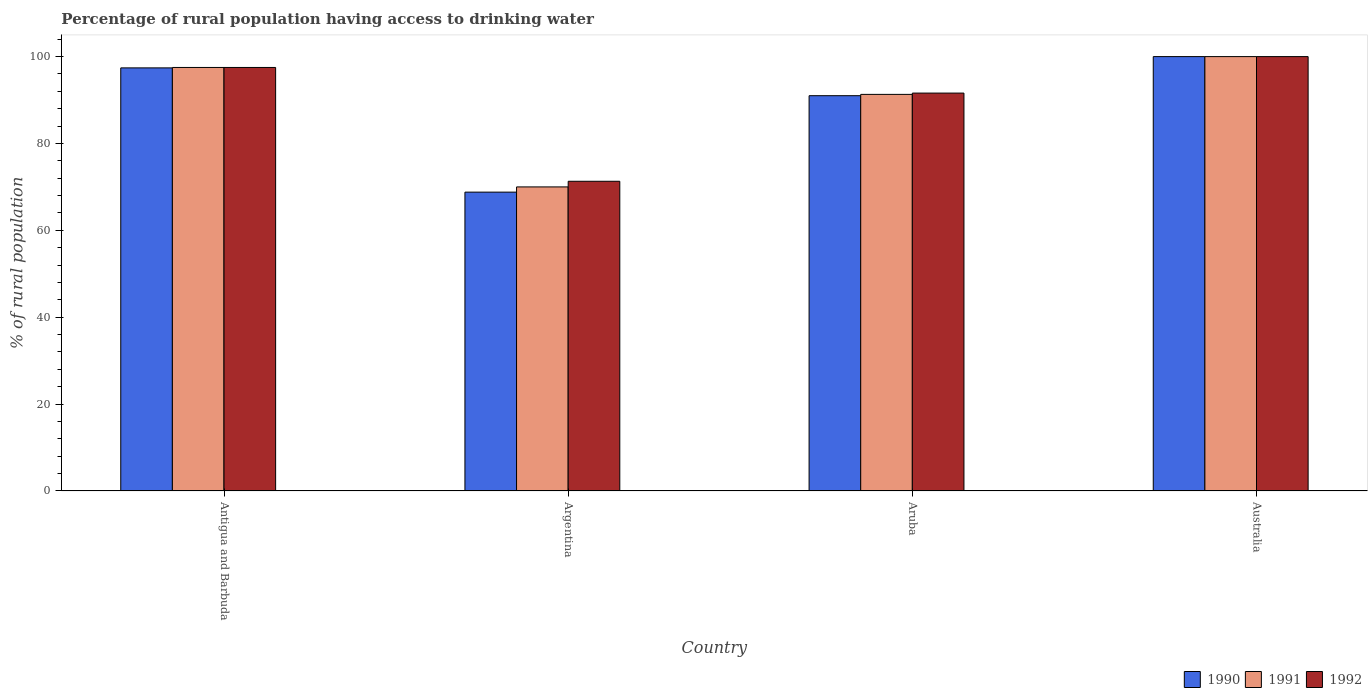How many different coloured bars are there?
Keep it short and to the point. 3. How many groups of bars are there?
Offer a terse response. 4. Are the number of bars per tick equal to the number of legend labels?
Provide a short and direct response. Yes. Are the number of bars on each tick of the X-axis equal?
Your answer should be compact. Yes. How many bars are there on the 2nd tick from the left?
Provide a short and direct response. 3. How many bars are there on the 2nd tick from the right?
Make the answer very short. 3. What is the label of the 1st group of bars from the left?
Ensure brevity in your answer.  Antigua and Barbuda. In how many cases, is the number of bars for a given country not equal to the number of legend labels?
Provide a succinct answer. 0. What is the percentage of rural population having access to drinking water in 1990 in Argentina?
Your answer should be very brief. 68.8. Across all countries, what is the minimum percentage of rural population having access to drinking water in 1992?
Provide a short and direct response. 71.3. In which country was the percentage of rural population having access to drinking water in 1992 minimum?
Give a very brief answer. Argentina. What is the total percentage of rural population having access to drinking water in 1990 in the graph?
Your answer should be very brief. 357.2. What is the difference between the percentage of rural population having access to drinking water in 1992 in Antigua and Barbuda and that in Argentina?
Offer a very short reply. 26.2. What is the difference between the percentage of rural population having access to drinking water in 1991 in Aruba and the percentage of rural population having access to drinking water in 1992 in Argentina?
Ensure brevity in your answer.  20. What is the average percentage of rural population having access to drinking water in 1991 per country?
Make the answer very short. 89.7. What is the difference between the percentage of rural population having access to drinking water of/in 1991 and percentage of rural population having access to drinking water of/in 1990 in Argentina?
Provide a short and direct response. 1.2. What is the ratio of the percentage of rural population having access to drinking water in 1991 in Aruba to that in Australia?
Your answer should be compact. 0.91. What is the difference between the highest and the second highest percentage of rural population having access to drinking water in 1990?
Keep it short and to the point. 6.4. What is the difference between the highest and the lowest percentage of rural population having access to drinking water in 1992?
Provide a short and direct response. 28.7. In how many countries, is the percentage of rural population having access to drinking water in 1991 greater than the average percentage of rural population having access to drinking water in 1991 taken over all countries?
Your response must be concise. 3. Is the sum of the percentage of rural population having access to drinking water in 1990 in Antigua and Barbuda and Aruba greater than the maximum percentage of rural population having access to drinking water in 1992 across all countries?
Your response must be concise. Yes. What does the 1st bar from the left in Antigua and Barbuda represents?
Make the answer very short. 1990. What does the 1st bar from the right in Australia represents?
Ensure brevity in your answer.  1992. What is the difference between two consecutive major ticks on the Y-axis?
Give a very brief answer. 20. Are the values on the major ticks of Y-axis written in scientific E-notation?
Your answer should be very brief. No. Does the graph contain any zero values?
Offer a terse response. No. What is the title of the graph?
Your answer should be compact. Percentage of rural population having access to drinking water. What is the label or title of the X-axis?
Your answer should be very brief. Country. What is the label or title of the Y-axis?
Provide a short and direct response. % of rural population. What is the % of rural population of 1990 in Antigua and Barbuda?
Your answer should be compact. 97.4. What is the % of rural population in 1991 in Antigua and Barbuda?
Make the answer very short. 97.5. What is the % of rural population of 1992 in Antigua and Barbuda?
Provide a succinct answer. 97.5. What is the % of rural population of 1990 in Argentina?
Make the answer very short. 68.8. What is the % of rural population of 1992 in Argentina?
Provide a short and direct response. 71.3. What is the % of rural population of 1990 in Aruba?
Ensure brevity in your answer.  91. What is the % of rural population in 1991 in Aruba?
Your answer should be very brief. 91.3. What is the % of rural population of 1992 in Aruba?
Offer a very short reply. 91.6. What is the % of rural population of 1990 in Australia?
Offer a terse response. 100. What is the % of rural population in 1991 in Australia?
Give a very brief answer. 100. Across all countries, what is the minimum % of rural population in 1990?
Offer a terse response. 68.8. Across all countries, what is the minimum % of rural population in 1991?
Make the answer very short. 70. Across all countries, what is the minimum % of rural population in 1992?
Ensure brevity in your answer.  71.3. What is the total % of rural population in 1990 in the graph?
Make the answer very short. 357.2. What is the total % of rural population of 1991 in the graph?
Your response must be concise. 358.8. What is the total % of rural population in 1992 in the graph?
Your response must be concise. 360.4. What is the difference between the % of rural population in 1990 in Antigua and Barbuda and that in Argentina?
Your answer should be compact. 28.6. What is the difference between the % of rural population of 1992 in Antigua and Barbuda and that in Argentina?
Provide a succinct answer. 26.2. What is the difference between the % of rural population of 1990 in Antigua and Barbuda and that in Australia?
Ensure brevity in your answer.  -2.6. What is the difference between the % of rural population in 1991 in Antigua and Barbuda and that in Australia?
Ensure brevity in your answer.  -2.5. What is the difference between the % of rural population in 1990 in Argentina and that in Aruba?
Your response must be concise. -22.2. What is the difference between the % of rural population in 1991 in Argentina and that in Aruba?
Your response must be concise. -21.3. What is the difference between the % of rural population of 1992 in Argentina and that in Aruba?
Your answer should be very brief. -20.3. What is the difference between the % of rural population in 1990 in Argentina and that in Australia?
Provide a succinct answer. -31.2. What is the difference between the % of rural population in 1992 in Argentina and that in Australia?
Offer a terse response. -28.7. What is the difference between the % of rural population of 1990 in Antigua and Barbuda and the % of rural population of 1991 in Argentina?
Make the answer very short. 27.4. What is the difference between the % of rural population in 1990 in Antigua and Barbuda and the % of rural population in 1992 in Argentina?
Your answer should be compact. 26.1. What is the difference between the % of rural population of 1991 in Antigua and Barbuda and the % of rural population of 1992 in Argentina?
Your answer should be compact. 26.2. What is the difference between the % of rural population of 1991 in Antigua and Barbuda and the % of rural population of 1992 in Aruba?
Your response must be concise. 5.9. What is the difference between the % of rural population of 1990 in Antigua and Barbuda and the % of rural population of 1991 in Australia?
Keep it short and to the point. -2.6. What is the difference between the % of rural population in 1990 in Antigua and Barbuda and the % of rural population in 1992 in Australia?
Your answer should be compact. -2.6. What is the difference between the % of rural population in 1991 in Antigua and Barbuda and the % of rural population in 1992 in Australia?
Offer a very short reply. -2.5. What is the difference between the % of rural population of 1990 in Argentina and the % of rural population of 1991 in Aruba?
Give a very brief answer. -22.5. What is the difference between the % of rural population in 1990 in Argentina and the % of rural population in 1992 in Aruba?
Offer a very short reply. -22.8. What is the difference between the % of rural population in 1991 in Argentina and the % of rural population in 1992 in Aruba?
Make the answer very short. -21.6. What is the difference between the % of rural population in 1990 in Argentina and the % of rural population in 1991 in Australia?
Give a very brief answer. -31.2. What is the difference between the % of rural population of 1990 in Argentina and the % of rural population of 1992 in Australia?
Your answer should be compact. -31.2. What is the difference between the % of rural population of 1990 in Aruba and the % of rural population of 1991 in Australia?
Provide a succinct answer. -9. What is the average % of rural population of 1990 per country?
Provide a short and direct response. 89.3. What is the average % of rural population in 1991 per country?
Give a very brief answer. 89.7. What is the average % of rural population of 1992 per country?
Offer a terse response. 90.1. What is the difference between the % of rural population in 1990 and % of rural population in 1992 in Antigua and Barbuda?
Keep it short and to the point. -0.1. What is the difference between the % of rural population in 1991 and % of rural population in 1992 in Antigua and Barbuda?
Your response must be concise. 0. What is the difference between the % of rural population of 1990 and % of rural population of 1991 in Argentina?
Make the answer very short. -1.2. What is the difference between the % of rural population of 1991 and % of rural population of 1992 in Argentina?
Make the answer very short. -1.3. What is the difference between the % of rural population in 1990 and % of rural population in 1992 in Aruba?
Offer a very short reply. -0.6. What is the difference between the % of rural population in 1990 and % of rural population in 1991 in Australia?
Your answer should be compact. 0. What is the difference between the % of rural population of 1991 and % of rural population of 1992 in Australia?
Keep it short and to the point. 0. What is the ratio of the % of rural population of 1990 in Antigua and Barbuda to that in Argentina?
Your answer should be very brief. 1.42. What is the ratio of the % of rural population of 1991 in Antigua and Barbuda to that in Argentina?
Provide a succinct answer. 1.39. What is the ratio of the % of rural population in 1992 in Antigua and Barbuda to that in Argentina?
Your answer should be compact. 1.37. What is the ratio of the % of rural population of 1990 in Antigua and Barbuda to that in Aruba?
Make the answer very short. 1.07. What is the ratio of the % of rural population of 1991 in Antigua and Barbuda to that in Aruba?
Ensure brevity in your answer.  1.07. What is the ratio of the % of rural population in 1992 in Antigua and Barbuda to that in Aruba?
Your response must be concise. 1.06. What is the ratio of the % of rural population of 1991 in Antigua and Barbuda to that in Australia?
Provide a succinct answer. 0.97. What is the ratio of the % of rural population of 1990 in Argentina to that in Aruba?
Provide a succinct answer. 0.76. What is the ratio of the % of rural population of 1991 in Argentina to that in Aruba?
Provide a short and direct response. 0.77. What is the ratio of the % of rural population in 1992 in Argentina to that in Aruba?
Make the answer very short. 0.78. What is the ratio of the % of rural population of 1990 in Argentina to that in Australia?
Offer a terse response. 0.69. What is the ratio of the % of rural population of 1992 in Argentina to that in Australia?
Your answer should be very brief. 0.71. What is the ratio of the % of rural population of 1990 in Aruba to that in Australia?
Your response must be concise. 0.91. What is the ratio of the % of rural population in 1991 in Aruba to that in Australia?
Keep it short and to the point. 0.91. What is the ratio of the % of rural population of 1992 in Aruba to that in Australia?
Offer a terse response. 0.92. What is the difference between the highest and the second highest % of rural population in 1990?
Make the answer very short. 2.6. What is the difference between the highest and the second highest % of rural population in 1991?
Your answer should be very brief. 2.5. What is the difference between the highest and the lowest % of rural population in 1990?
Offer a terse response. 31.2. What is the difference between the highest and the lowest % of rural population of 1992?
Provide a succinct answer. 28.7. 